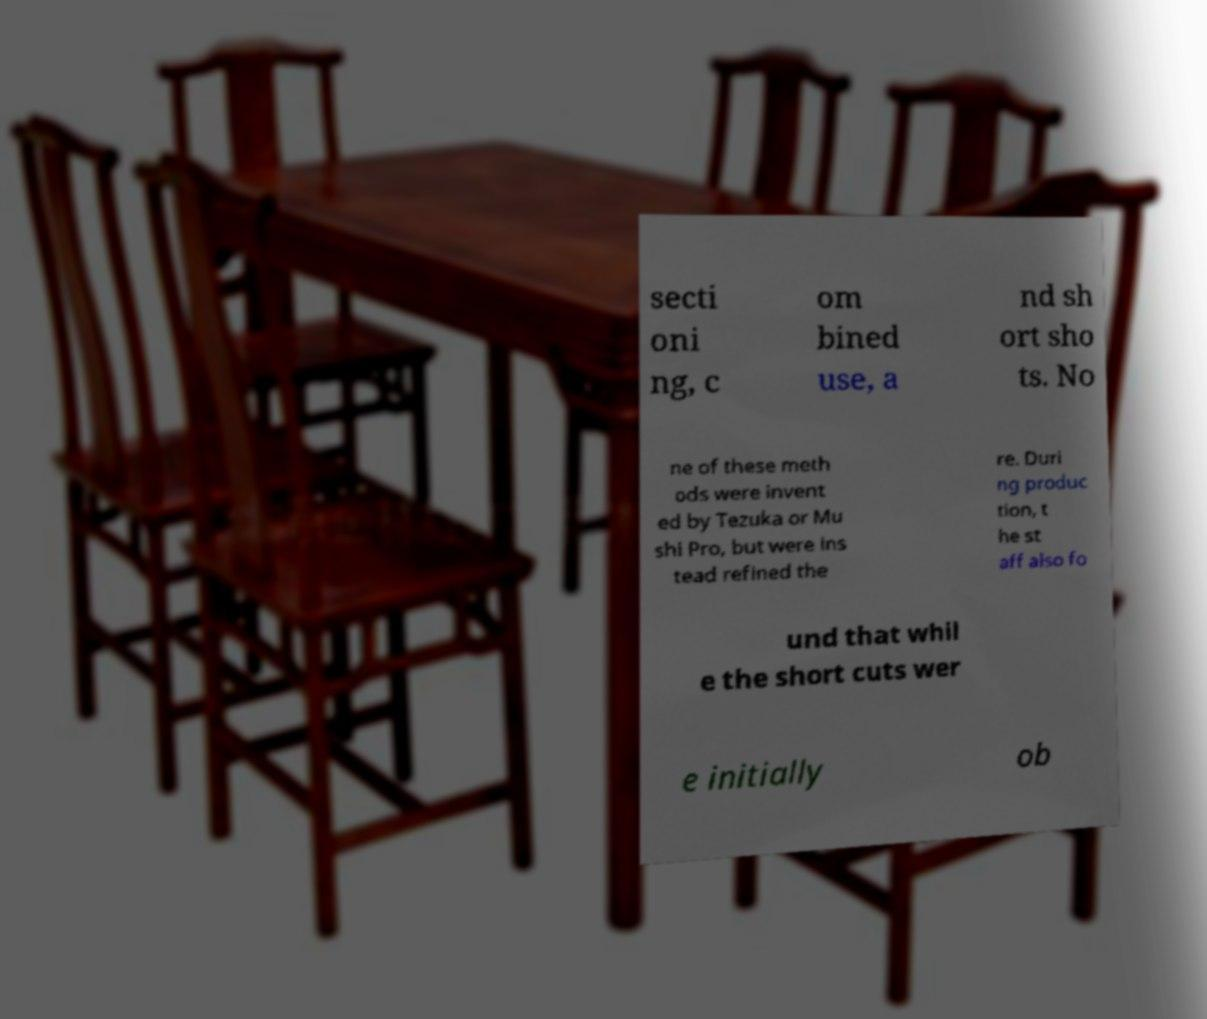I need the written content from this picture converted into text. Can you do that? secti oni ng, c om bined use, a nd sh ort sho ts. No ne of these meth ods were invent ed by Tezuka or Mu shi Pro, but were ins tead refined the re. Duri ng produc tion, t he st aff also fo und that whil e the short cuts wer e initially ob 